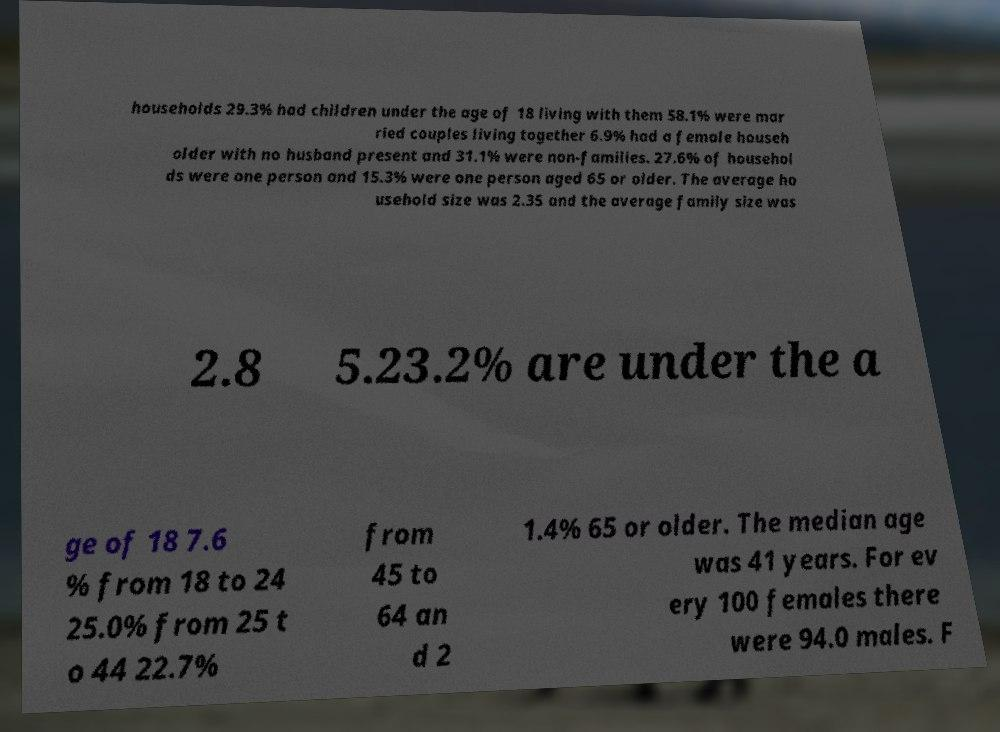Could you assist in decoding the text presented in this image and type it out clearly? households 29.3% had children under the age of 18 living with them 58.1% were mar ried couples living together 6.9% had a female househ older with no husband present and 31.1% were non-families. 27.6% of househol ds were one person and 15.3% were one person aged 65 or older. The average ho usehold size was 2.35 and the average family size was 2.8 5.23.2% are under the a ge of 18 7.6 % from 18 to 24 25.0% from 25 t o 44 22.7% from 45 to 64 an d 2 1.4% 65 or older. The median age was 41 years. For ev ery 100 females there were 94.0 males. F 